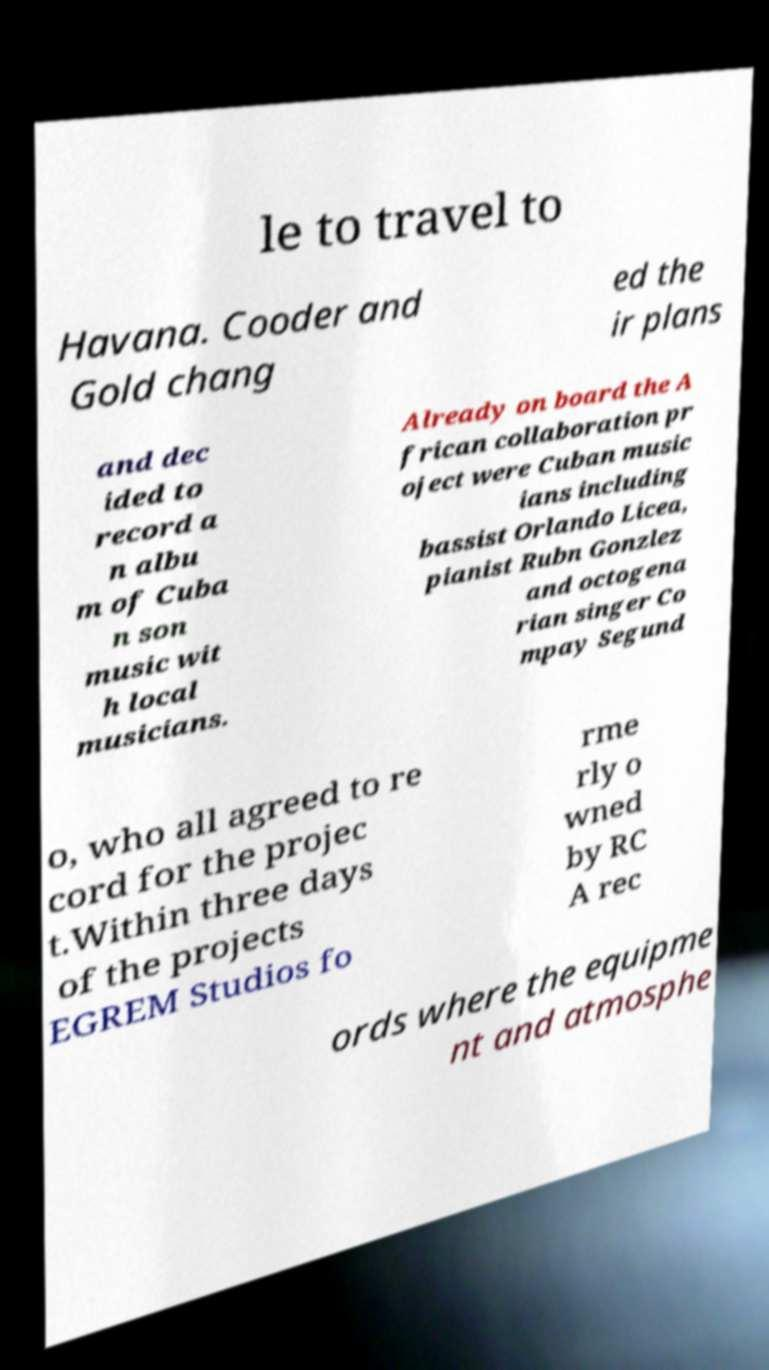For documentation purposes, I need the text within this image transcribed. Could you provide that? le to travel to Havana. Cooder and Gold chang ed the ir plans and dec ided to record a n albu m of Cuba n son music wit h local musicians. Already on board the A frican collaboration pr oject were Cuban music ians including bassist Orlando Licea, pianist Rubn Gonzlez and octogena rian singer Co mpay Segund o, who all agreed to re cord for the projec t.Within three days of the projects EGREM Studios fo rme rly o wned by RC A rec ords where the equipme nt and atmosphe 